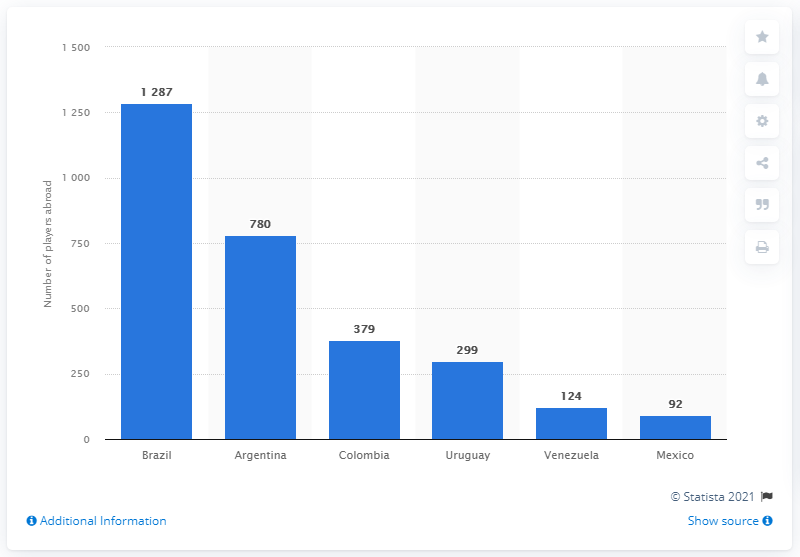Outline some significant characteristics in this image. The country that sent the most soccer players to play outside of their homeland was Brazil. 